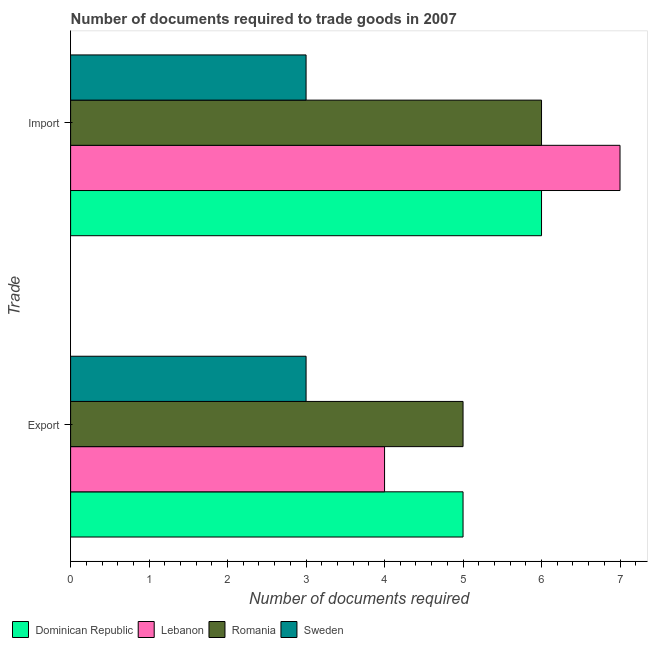How many different coloured bars are there?
Keep it short and to the point. 4. How many groups of bars are there?
Offer a terse response. 2. How many bars are there on the 2nd tick from the top?
Give a very brief answer. 4. How many bars are there on the 1st tick from the bottom?
Offer a terse response. 4. What is the label of the 1st group of bars from the top?
Give a very brief answer. Import. What is the number of documents required to export goods in Lebanon?
Provide a short and direct response. 4. Across all countries, what is the maximum number of documents required to import goods?
Your answer should be compact. 7. Across all countries, what is the minimum number of documents required to export goods?
Provide a short and direct response. 3. In which country was the number of documents required to export goods maximum?
Keep it short and to the point. Dominican Republic. What is the total number of documents required to import goods in the graph?
Provide a short and direct response. 22. What is the difference between the number of documents required to import goods in Romania and that in Sweden?
Provide a succinct answer. 3. What is the difference between the number of documents required to export goods in Dominican Republic and the number of documents required to import goods in Sweden?
Offer a very short reply. 2. What is the average number of documents required to import goods per country?
Provide a succinct answer. 5.5. What is the difference between the number of documents required to export goods and number of documents required to import goods in Lebanon?
Make the answer very short. -3. In how many countries, is the number of documents required to export goods greater than 2 ?
Give a very brief answer. 4. What is the ratio of the number of documents required to import goods in Lebanon to that in Sweden?
Your answer should be very brief. 2.33. Is the number of documents required to import goods in Romania less than that in Dominican Republic?
Provide a succinct answer. No. What does the 3rd bar from the top in Import represents?
Give a very brief answer. Lebanon. What does the 4th bar from the bottom in Export represents?
Give a very brief answer. Sweden. Are all the bars in the graph horizontal?
Your answer should be compact. Yes. What is the difference between two consecutive major ticks on the X-axis?
Offer a very short reply. 1. Are the values on the major ticks of X-axis written in scientific E-notation?
Your response must be concise. No. Does the graph contain any zero values?
Ensure brevity in your answer.  No. Does the graph contain grids?
Your response must be concise. No. What is the title of the graph?
Provide a succinct answer. Number of documents required to trade goods in 2007. Does "Bhutan" appear as one of the legend labels in the graph?
Offer a terse response. No. What is the label or title of the X-axis?
Ensure brevity in your answer.  Number of documents required. What is the label or title of the Y-axis?
Provide a succinct answer. Trade. What is the Number of documents required in Lebanon in Export?
Offer a terse response. 4. What is the Number of documents required in Sweden in Export?
Provide a succinct answer. 3. What is the Number of documents required in Lebanon in Import?
Ensure brevity in your answer.  7. What is the Number of documents required of Romania in Import?
Your response must be concise. 6. What is the Number of documents required of Sweden in Import?
Offer a terse response. 3. What is the total Number of documents required of Romania in the graph?
Your answer should be very brief. 11. What is the difference between the Number of documents required of Romania in Export and that in Import?
Make the answer very short. -1. What is the difference between the Number of documents required in Sweden in Export and that in Import?
Make the answer very short. 0. What is the difference between the Number of documents required of Dominican Republic in Export and the Number of documents required of Romania in Import?
Provide a succinct answer. -1. What is the difference between the Number of documents required of Dominican Republic in Export and the Number of documents required of Sweden in Import?
Offer a very short reply. 2. What is the difference between the Number of documents required of Romania in Export and the Number of documents required of Sweden in Import?
Keep it short and to the point. 2. What is the average Number of documents required in Romania per Trade?
Provide a succinct answer. 5.5. What is the difference between the Number of documents required of Lebanon and Number of documents required of Romania in Export?
Provide a succinct answer. -1. What is the difference between the Number of documents required of Lebanon and Number of documents required of Sweden in Import?
Your answer should be very brief. 4. What is the difference between the Number of documents required of Romania and Number of documents required of Sweden in Import?
Offer a very short reply. 3. What is the ratio of the Number of documents required of Dominican Republic in Export to that in Import?
Give a very brief answer. 0.83. What is the ratio of the Number of documents required in Lebanon in Export to that in Import?
Provide a succinct answer. 0.57. What is the ratio of the Number of documents required of Romania in Export to that in Import?
Provide a short and direct response. 0.83. What is the difference between the highest and the second highest Number of documents required in Dominican Republic?
Your response must be concise. 1. What is the difference between the highest and the second highest Number of documents required in Sweden?
Provide a short and direct response. 0. What is the difference between the highest and the lowest Number of documents required in Lebanon?
Ensure brevity in your answer.  3. What is the difference between the highest and the lowest Number of documents required of Romania?
Give a very brief answer. 1. What is the difference between the highest and the lowest Number of documents required of Sweden?
Keep it short and to the point. 0. 